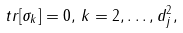Convert formula to latex. <formula><loc_0><loc_0><loc_500><loc_500>\ t r [ \sigma _ { k } ] = 0 , \, k = 2 , \dots , d _ { j } ^ { 2 } ,</formula> 